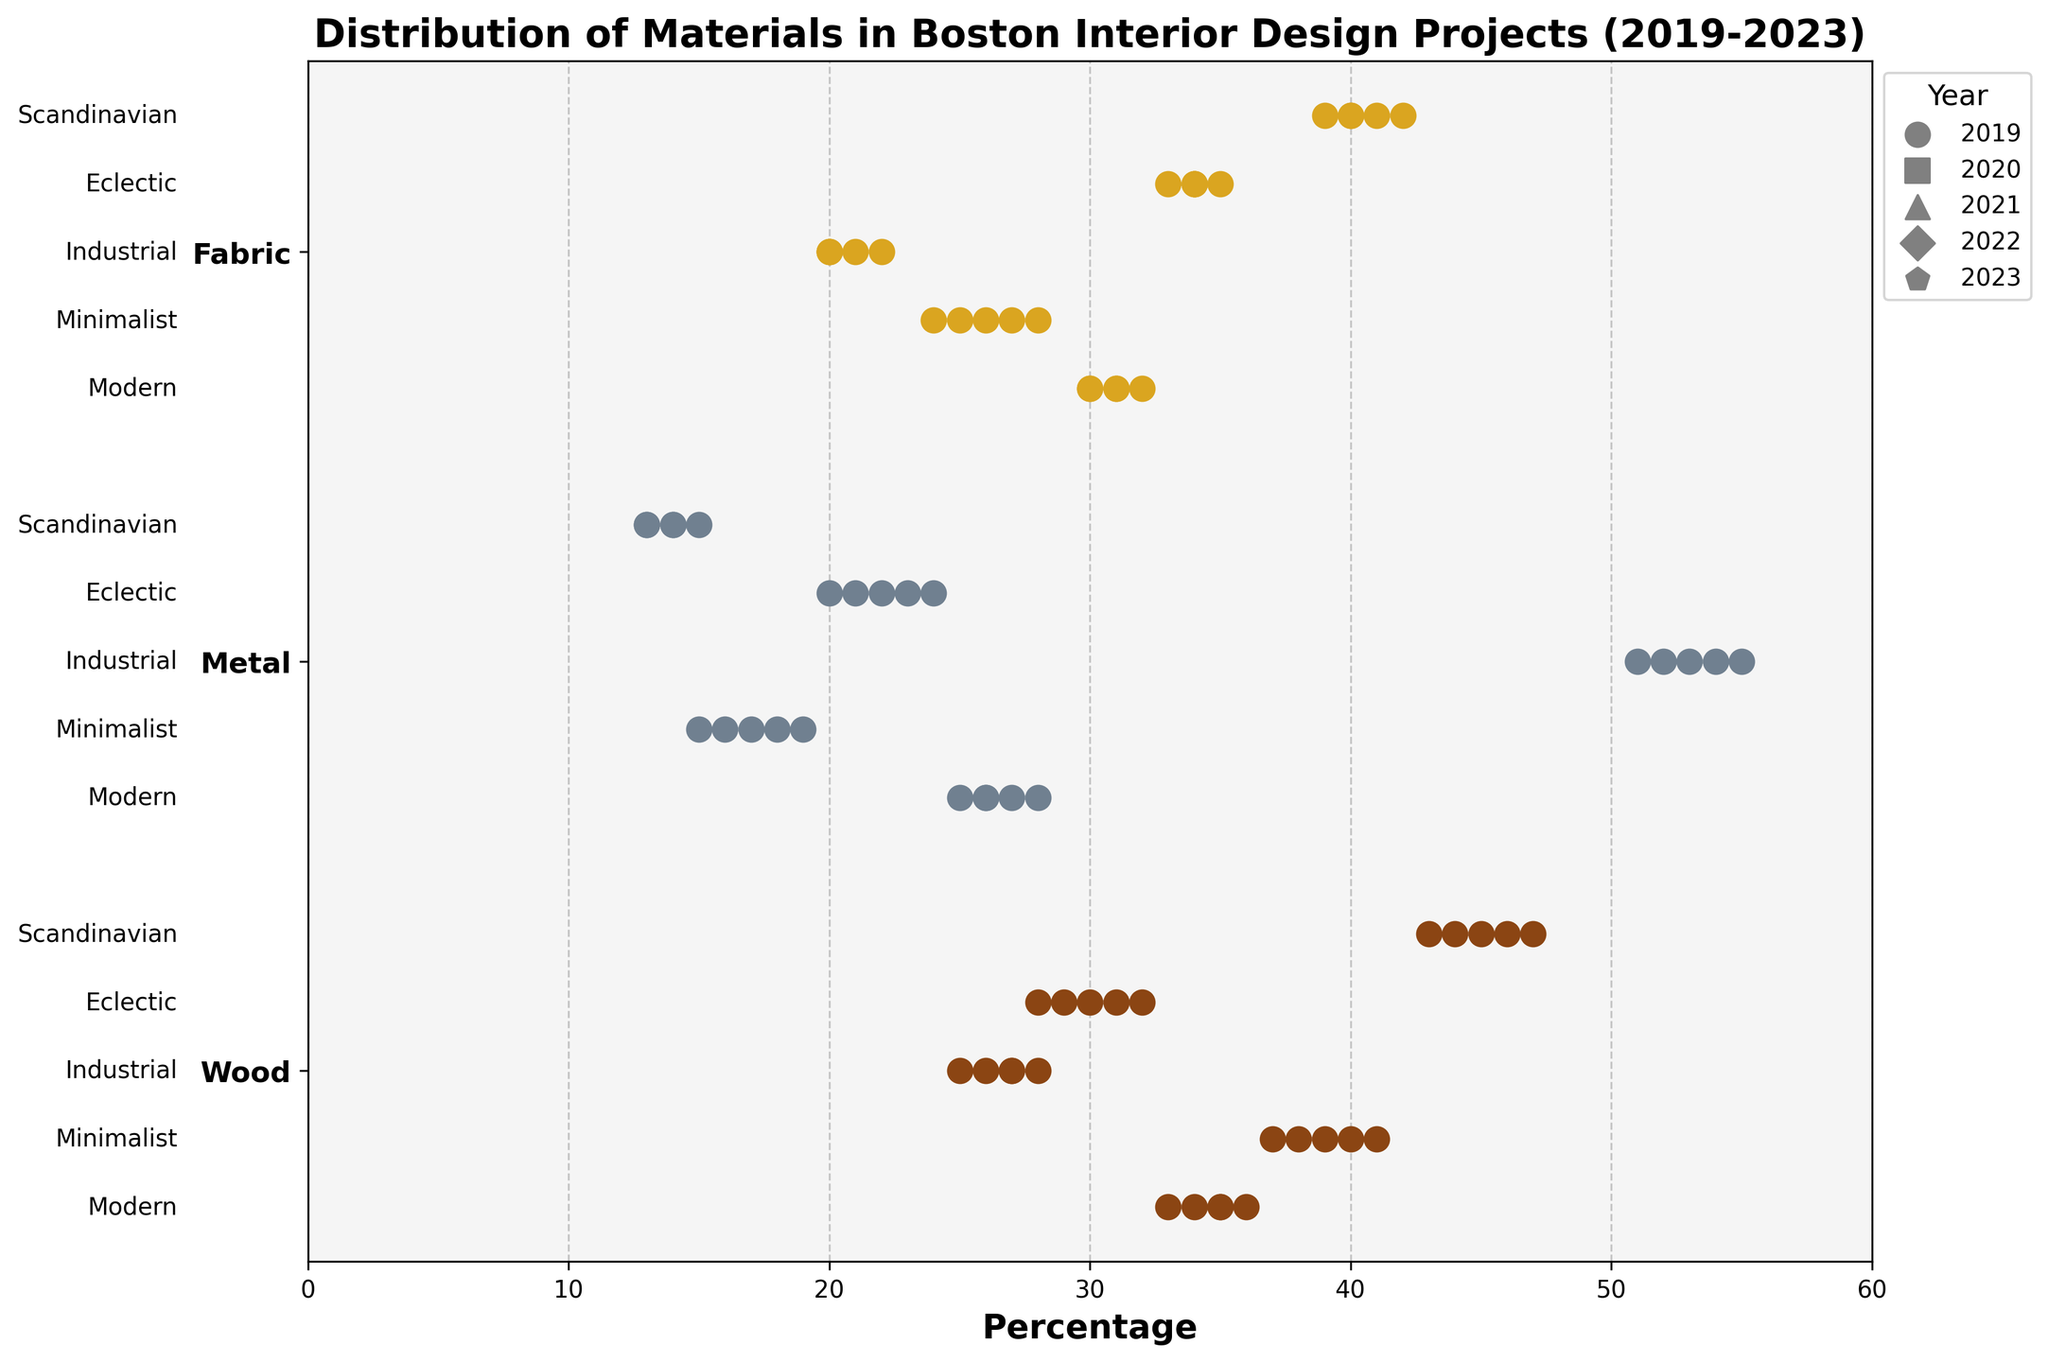Which material has the highest percentage in Scandinavian design theme in 2023? Find the values for each material in the Scandinavian design theme for 2023. The percentages are: Wood (43%), Metal (14%), and Fabric (41%). The highest value is 43%.
Answer: Wood What is the range of percentages for Wood in the Eclectic theme across all years? Identify the smallest and largest percentage values for Wood in the Eclectic theme from 2019 to 2023. These values are 28% (2020) and 32% (2023). The range is 32% - 28% = 4%.
Answer: 4% Which material shows the most consistent percentage for the Minimalist theme from 2019 to 2023? Wood has the following percentages for Minimalist from 2019 to 2023: 40%, 38%, 39%, 37%, 41%. The differences between consecutive years are small. Compare with other materials: Metal (15%, 17%, 18%, 16%, 19%) and Fabric (25%, 27%, 26%, 28%, 24%). The differences for Metal and Fabric are slightly larger.
Answer: Wood Does the Modern theme favor any particular material more than others in 2023? Compare the percentages of materials for the Modern theme in 2023. These are: Wood (35%), Metal (26%), Fabric (31%). Wood has the highest percentage.
Answer: Wood What is the average percentage of Metal in the Industrial theme over the last 5 years? List the percentages for Metal in the Industrial theme from 2019-2023: 55%, 53%, 54%, 52%, 51%. Average = (55 + 53 + 54 + 52 + 51) / 5 = 265 / 5 = 53.
Answer: 53 Which year had the lowest percentage of Fabric in the Modern theme? Look at the percentages of Fabric in the Modern theme for each year: 2019 (30%), 2020 (32%), 2021 (31%), 2022 (30%), 2023 (31%). The lowest is 30% in 2019 and 2022.
Answer: 2019, 2022 How does the distribution of Metal in the Scandinavian theme differ between 2019 and 2023? Compare the percentage values for Metal in the Scandinavian theme from 2019 (15%) and 2023 (14%). The change is minimal with a difference of 1%.
Answer: Minimal difference What is the maximum percentage change for Fabric in the Eclectic theme from the previous year? Calculate the percentage changes for Fabric in the Eclectic theme between consecutive years: 2019-2020 (35%-34%=1%), 2020-2021 (34%-34%=0%), 2021-2022 (34%-33%=1%), 2022-2023 (33%-34%=1%). The maximum change is 1%.
Answer: 1% Is there a trend in the percentage of Wood in the Modern theme over the years? Look at the values for Wood in the Modern theme from 2019-2023: 2019 (35%), 2020 (33%), 2021 (36%), 2022 (34%), 2023 (35%). Calculate the changes: 33 to 36 (up), 36 to 34 (down), 34 to 35 (up), overall, it fluctuates but shows no consistent trend.
Answer: No consistent trend 